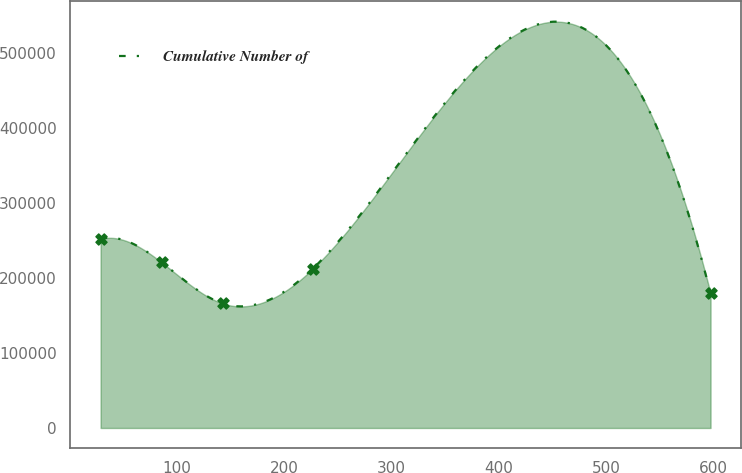Convert chart to OTSL. <chart><loc_0><loc_0><loc_500><loc_500><line_chart><ecel><fcel>Cumulative Number of<nl><fcel>29.11<fcel>252197<nl><fcel>85.93<fcel>220894<nl><fcel>142.75<fcel>166116<nl><fcel>226.63<fcel>212286<nl><fcel>597.27<fcel>179565<nl></chart> 